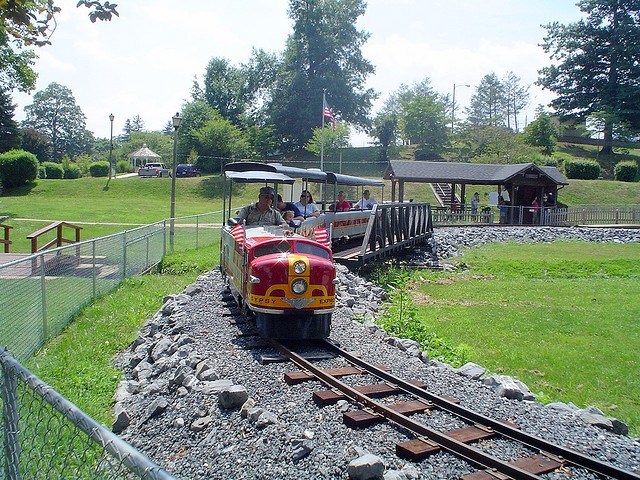Describe the objects in this image and their specific colors. I can see train in maroon, black, gray, and olive tones, people in maroon, gray, black, and darkgray tones, truck in maroon, gray, black, and darkgray tones, people in maroon, gray, and black tones, and truck in maroon, navy, black, blue, and gray tones in this image. 